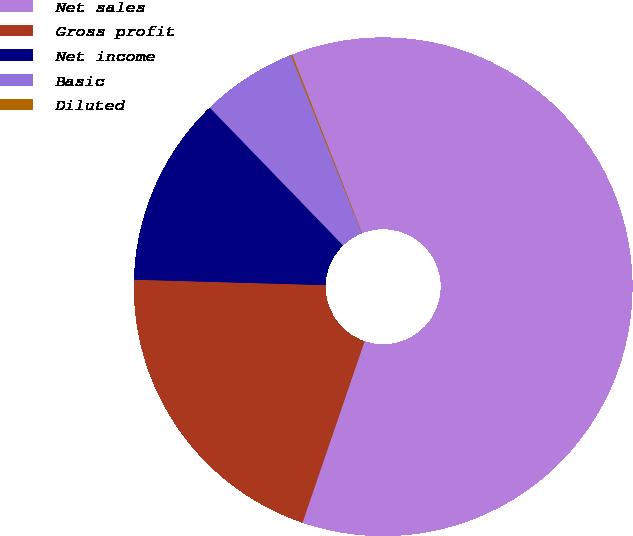<chart> <loc_0><loc_0><loc_500><loc_500><pie_chart><fcel>Net sales<fcel>Gross profit<fcel>Net income<fcel>Basic<fcel>Diluted<nl><fcel>61.2%<fcel>20.21%<fcel>12.31%<fcel>6.2%<fcel>0.09%<nl></chart> 